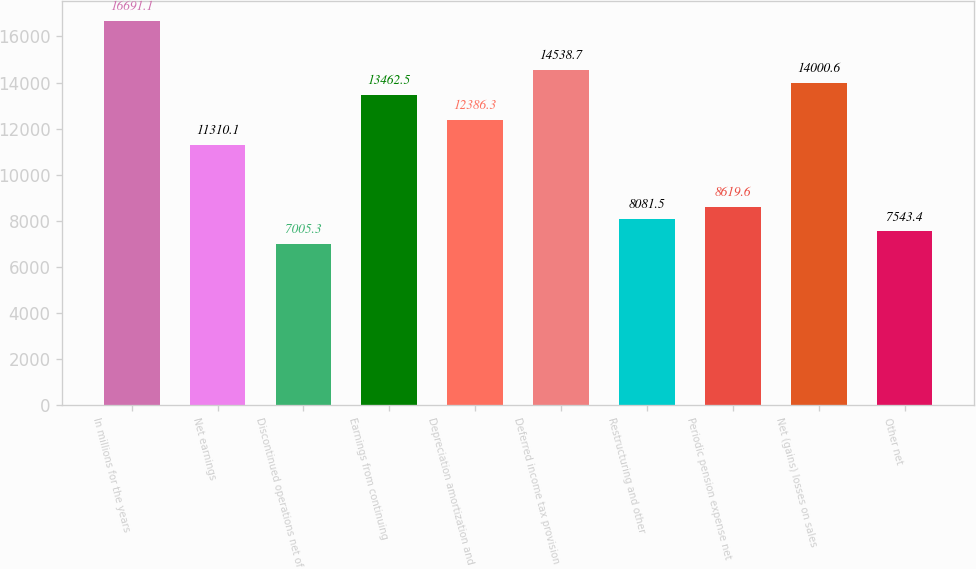Convert chart to OTSL. <chart><loc_0><loc_0><loc_500><loc_500><bar_chart><fcel>In millions for the years<fcel>Net earnings<fcel>Discontinued operations net of<fcel>Earnings from continuing<fcel>Depreciation amortization and<fcel>Deferred income tax provision<fcel>Restructuring and other<fcel>Periodic pension expense net<fcel>Net (gains) losses on sales<fcel>Other net<nl><fcel>16691.1<fcel>11310.1<fcel>7005.3<fcel>13462.5<fcel>12386.3<fcel>14538.7<fcel>8081.5<fcel>8619.6<fcel>14000.6<fcel>7543.4<nl></chart> 